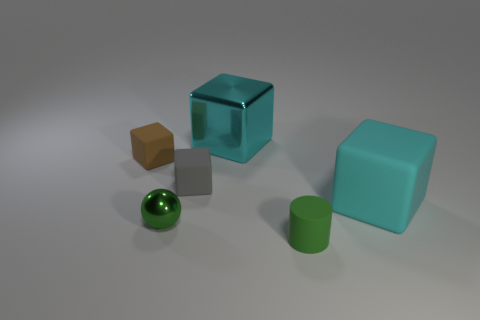Subtract all gray matte blocks. How many blocks are left? 3 Add 4 tiny rubber cylinders. How many objects exist? 10 Subtract all brown cubes. How many cubes are left? 3 Subtract all cylinders. How many objects are left? 5 Subtract 1 balls. How many balls are left? 0 Subtract all yellow blocks. Subtract all blue cylinders. How many blocks are left? 4 Subtract all brown cubes. How many red spheres are left? 0 Subtract all big cyan shiny cubes. Subtract all tiny cyan spheres. How many objects are left? 5 Add 3 cyan rubber cubes. How many cyan rubber cubes are left? 4 Add 3 big yellow matte cylinders. How many big yellow matte cylinders exist? 3 